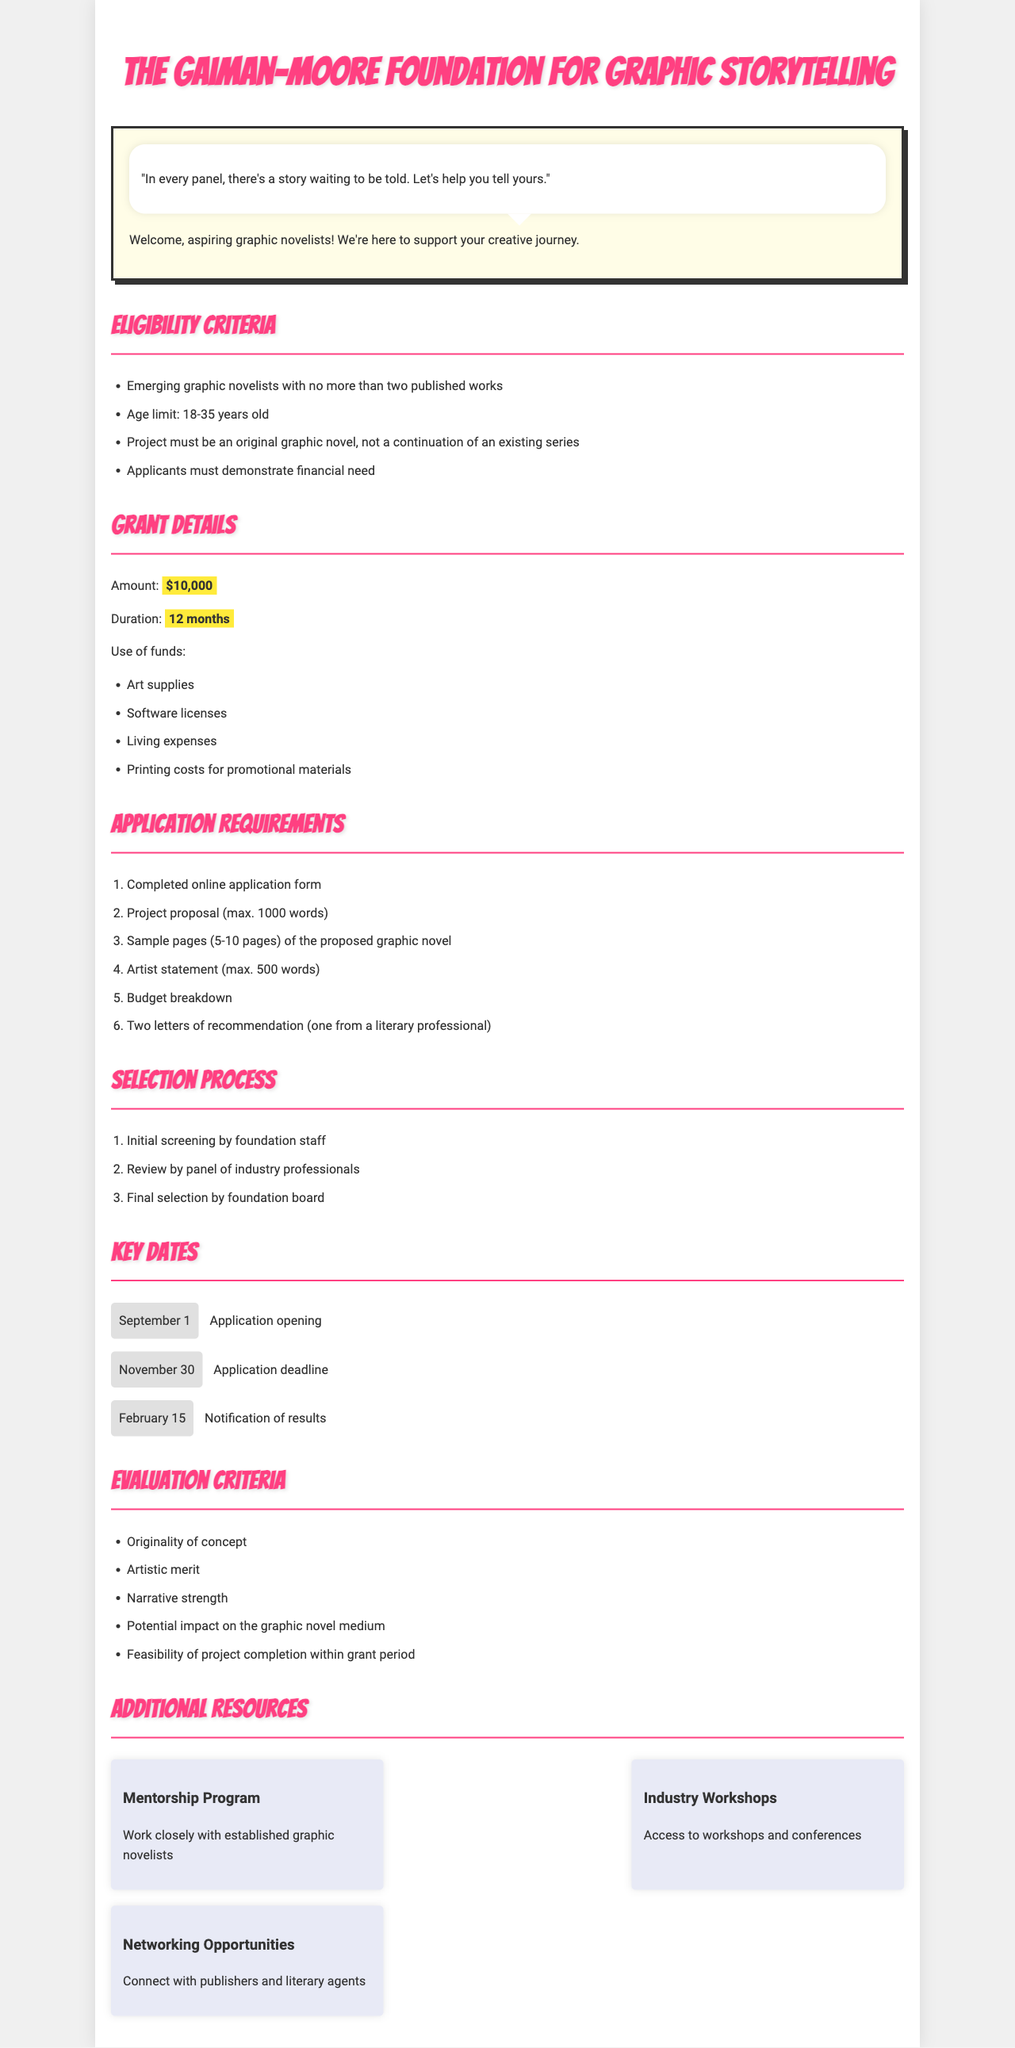What is the maximum age limit for applicants? The maximum age limit is stated directly in the eligibility criteria.
Answer: 35 years old What is the grant amount provided by the foundation? The grant amount is explicitly mentioned in the grant details section.
Answer: $10,000 What is the duration of the grant? The duration of the grant is outlined in the grant details section.
Answer: 12 months How many letters of recommendation are required? The number of recommendation letters is specified in the application requirements.
Answer: Two When is the application deadline? The application deadline is provided under the key dates section.
Answer: November 30 What is one of the evaluation criteria? An example of evaluation criteria can be found in the evaluation criteria section.
Answer: Originality of concept What must be included in the project proposal? The project proposal's word limit and general content are described in the application requirements.
Answer: Maximum 1000 words Who reviews the applications? The document describes the review process which includes multiple parties.
Answer: Panel of industry professionals What type of project is eligible for funding? The type of project eligibility can be found under the eligibility criteria.
Answer: Original graphic novel 